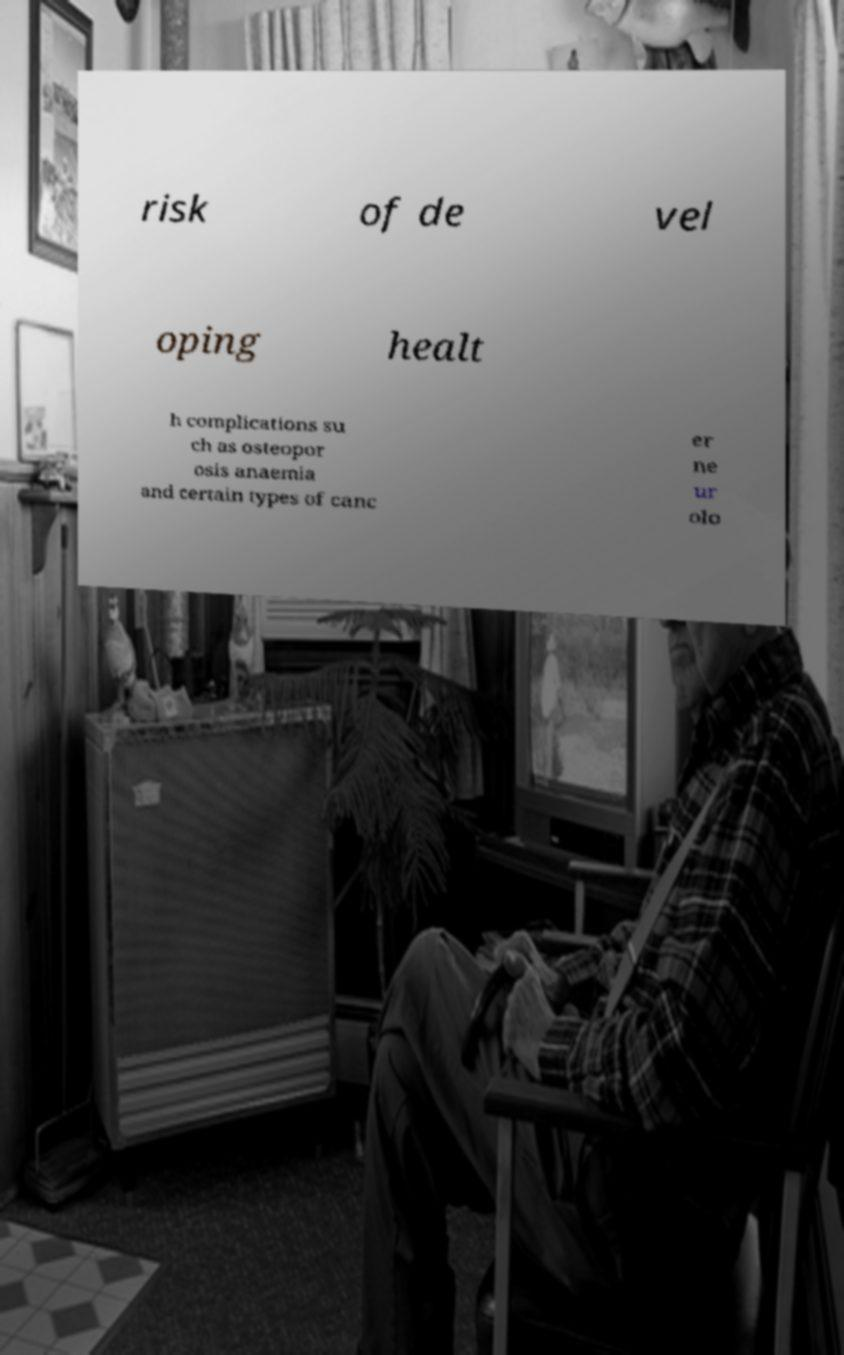There's text embedded in this image that I need extracted. Can you transcribe it verbatim? risk of de vel oping healt h complications su ch as osteopor osis anaemia and certain types of canc er ne ur olo 